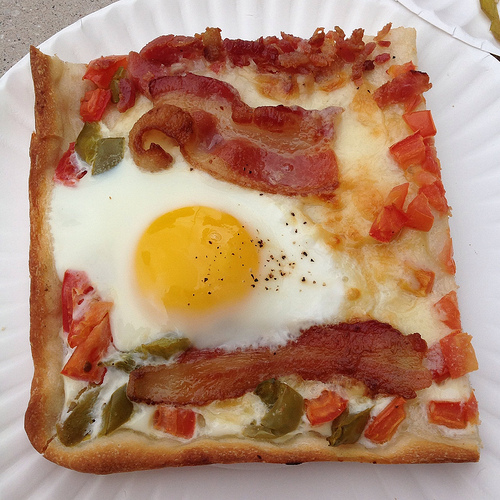Please provide a short description for this region: [0.14, 0.86, 0.96, 0.95]. This region captures the deliciously browned crust of the breakfast pizza, featuring a slightly charred and crispy texture that contrasts with the toppings. 